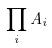<formula> <loc_0><loc_0><loc_500><loc_500>\prod _ { i } A _ { i }</formula> 